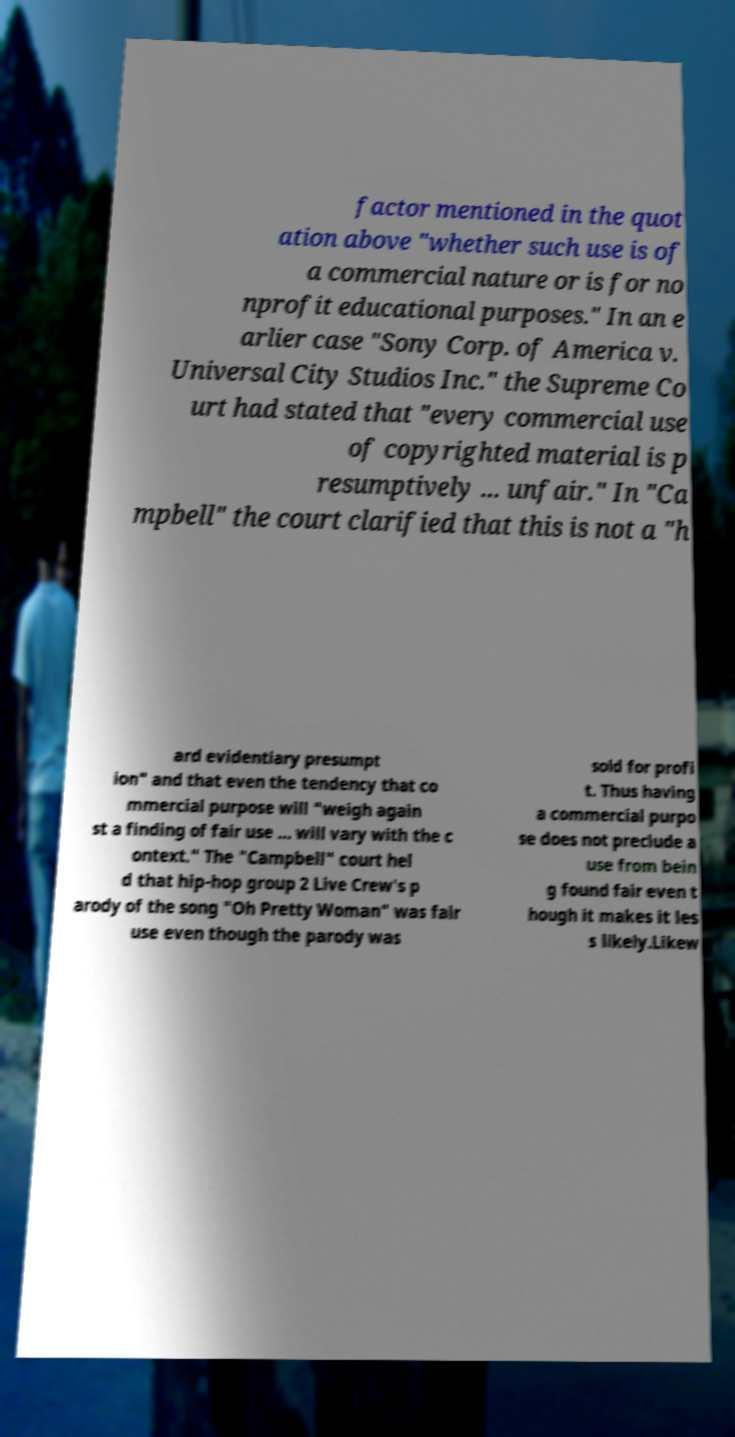For documentation purposes, I need the text within this image transcribed. Could you provide that? factor mentioned in the quot ation above "whether such use is of a commercial nature or is for no nprofit educational purposes." In an e arlier case "Sony Corp. of America v. Universal City Studios Inc." the Supreme Co urt had stated that "every commercial use of copyrighted material is p resumptively ... unfair." In "Ca mpbell" the court clarified that this is not a "h ard evidentiary presumpt ion" and that even the tendency that co mmercial purpose will "weigh again st a finding of fair use ... will vary with the c ontext." The "Campbell" court hel d that hip-hop group 2 Live Crew's p arody of the song "Oh Pretty Woman" was fair use even though the parody was sold for profi t. Thus having a commercial purpo se does not preclude a use from bein g found fair even t hough it makes it les s likely.Likew 